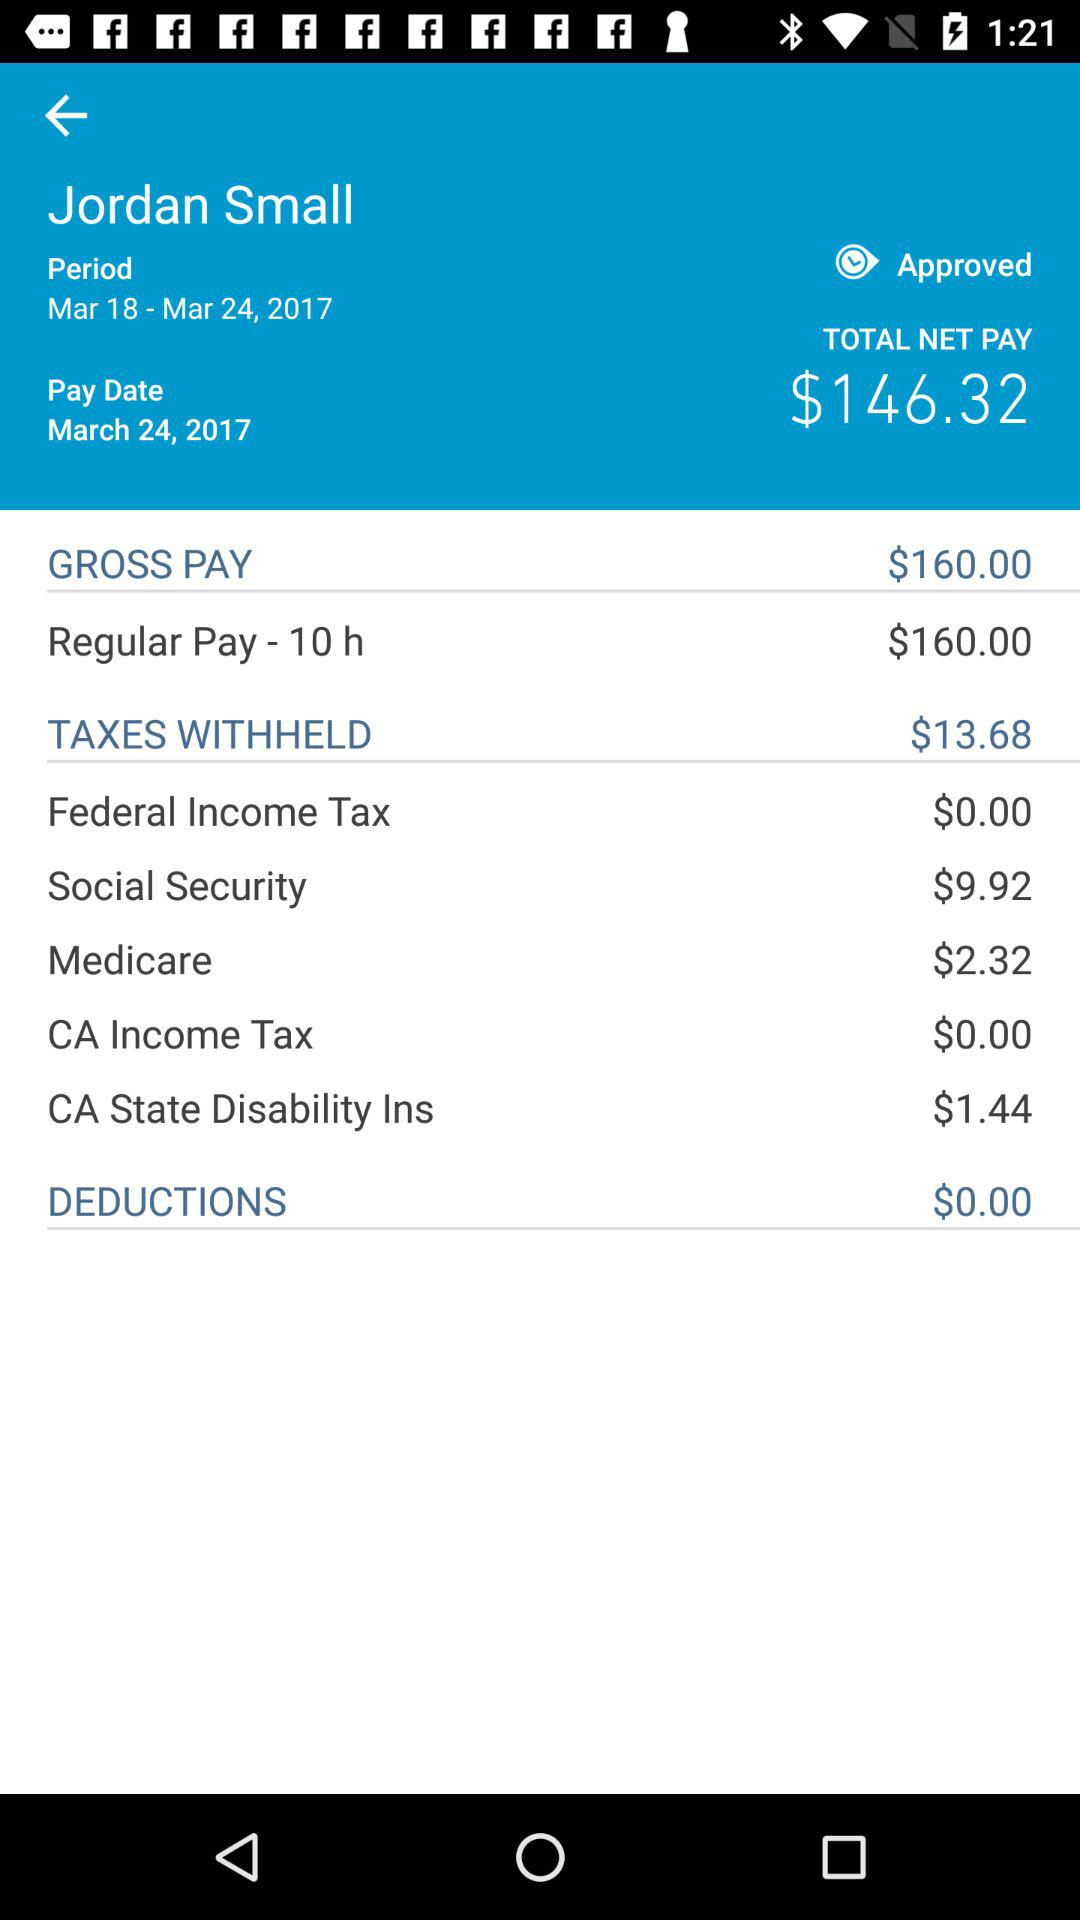How much was the worker paid per hour?
Answer the question using a single word or phrase. $16.00 